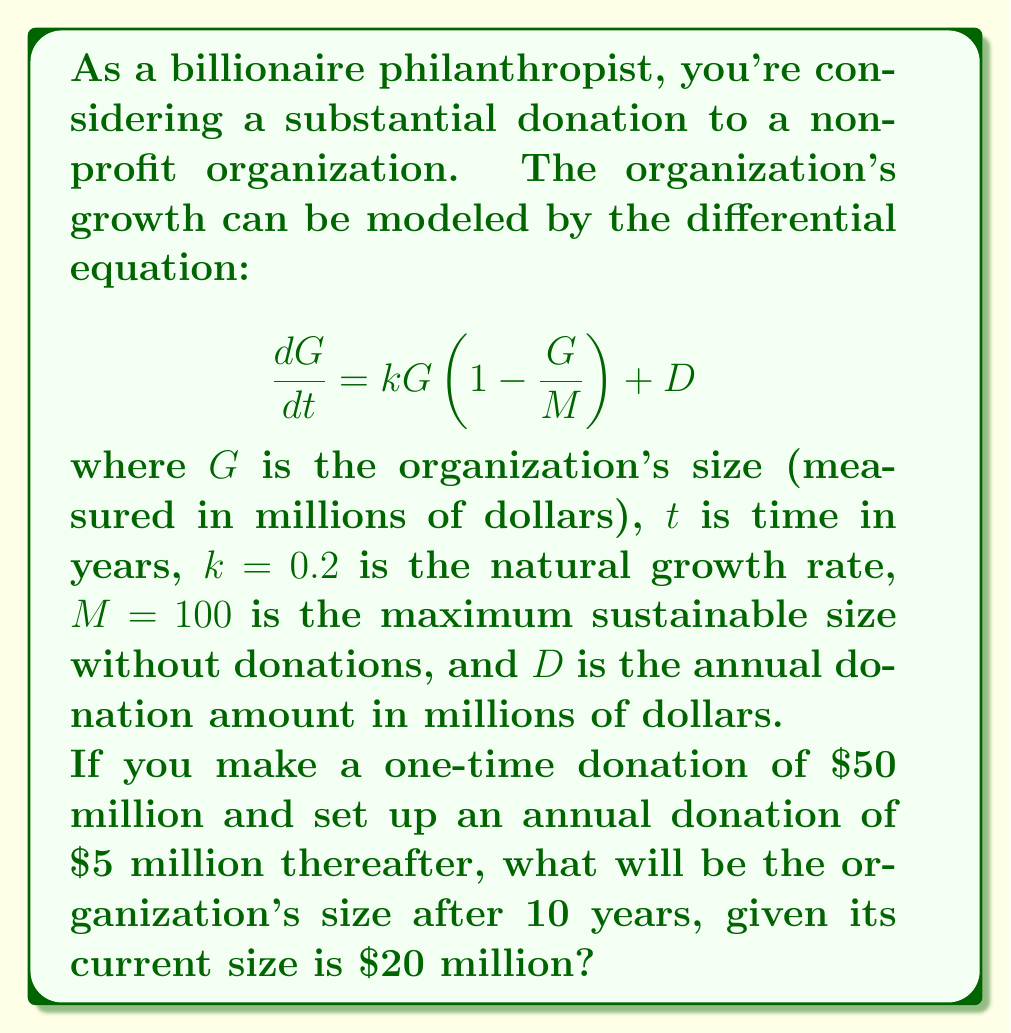Give your solution to this math problem. Let's approach this step-by-step:

1) First, we need to solve the differential equation. This is a modified logistic growth equation with a constant term.

2) The general solution to this equation is:

   $$G(t) = \frac{M(kG_0 + D)e^{(k+\frac{D}{M})t}}{kM + (kG_0 + D)e^{(k+\frac{D}{M})t}} - \frac{D}{k}$$

   where $G_0$ is the initial size.

3) We're given:
   $k = 0.2$, $M = 100$, $D = 5$ (annual donation), $G_0 = 20 + 50 = 70$ (initial size + one-time donation)

4) Substituting these values:

   $$G(t) = \frac{100(0.2 \cdot 70 + 5)e^{(0.2+\frac{5}{100})t}}{0.2 \cdot 100 + (0.2 \cdot 70 + 5)e^{(0.2+\frac{5}{100})t}} - \frac{5}{0.2}$$

5) Simplify:

   $$G(t) = \frac{1900e^{0.25t}}{20 + 19e^{0.25t}} - 25$$

6) We want to find $G(10)$:

   $$G(10) = \frac{1900e^{2.5}}{20 + 19e^{2.5}} - 25$$

7) Calculate:
   $e^{2.5} \approx 12.1825$
   
   $$G(10) = \frac{1900 \cdot 12.1825}{20 + 19 \cdot 12.1825} - 25 \approx 86.8713$$

Therefore, after 10 years, the organization's size will be approximately $86.87 million.
Answer: $86.87 million 